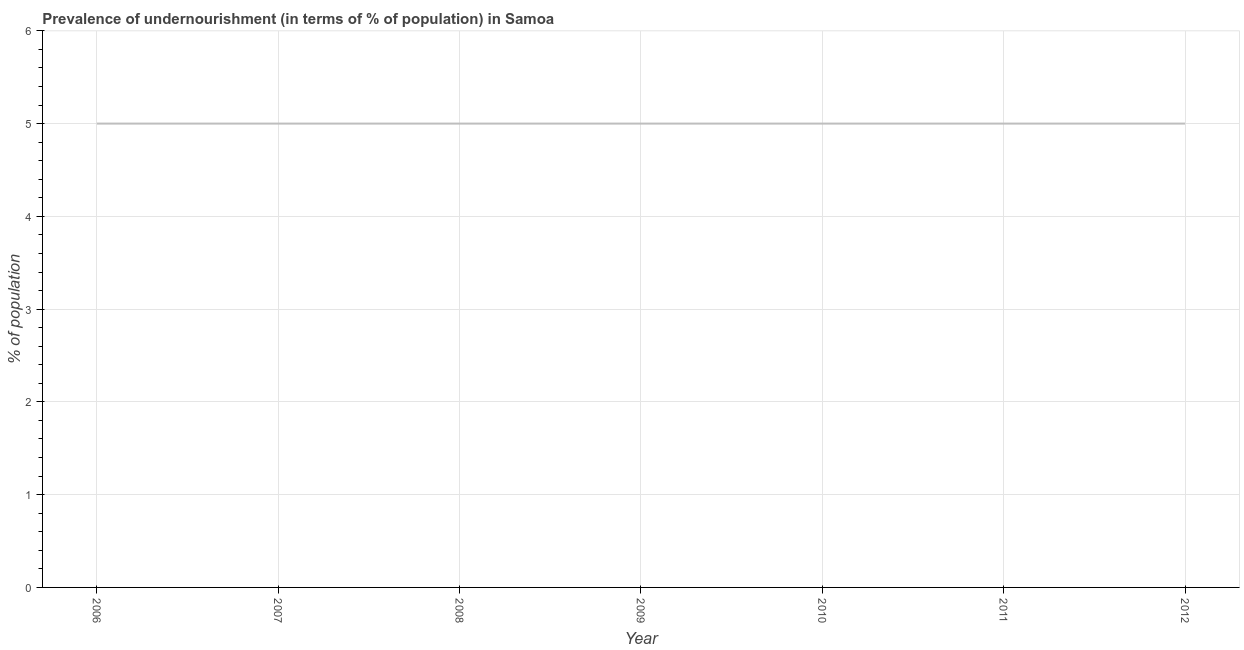What is the percentage of undernourished population in 2009?
Your answer should be compact. 5. Across all years, what is the maximum percentage of undernourished population?
Offer a terse response. 5. In which year was the percentage of undernourished population maximum?
Make the answer very short. 2006. What is the difference between the percentage of undernourished population in 2009 and 2011?
Offer a very short reply. 0. What is the median percentage of undernourished population?
Provide a succinct answer. 5. What is the ratio of the percentage of undernourished population in 2006 to that in 2011?
Keep it short and to the point. 1. Is the percentage of undernourished population in 2006 less than that in 2010?
Ensure brevity in your answer.  No. What is the difference between the highest and the second highest percentage of undernourished population?
Give a very brief answer. 0. In how many years, is the percentage of undernourished population greater than the average percentage of undernourished population taken over all years?
Your answer should be very brief. 0. Does the percentage of undernourished population monotonically increase over the years?
Ensure brevity in your answer.  No. How many lines are there?
Offer a very short reply. 1. How many years are there in the graph?
Provide a succinct answer. 7. Are the values on the major ticks of Y-axis written in scientific E-notation?
Keep it short and to the point. No. Does the graph contain any zero values?
Make the answer very short. No. What is the title of the graph?
Offer a terse response. Prevalence of undernourishment (in terms of % of population) in Samoa. What is the label or title of the Y-axis?
Your answer should be compact. % of population. What is the % of population of 2009?
Ensure brevity in your answer.  5. What is the % of population in 2011?
Provide a short and direct response. 5. What is the % of population in 2012?
Your answer should be very brief. 5. What is the difference between the % of population in 2006 and 2008?
Make the answer very short. 0. What is the difference between the % of population in 2006 and 2009?
Offer a very short reply. 0. What is the difference between the % of population in 2006 and 2010?
Provide a short and direct response. 0. What is the difference between the % of population in 2007 and 2009?
Your response must be concise. 0. What is the difference between the % of population in 2009 and 2012?
Make the answer very short. 0. What is the difference between the % of population in 2010 and 2011?
Keep it short and to the point. 0. What is the difference between the % of population in 2011 and 2012?
Provide a succinct answer. 0. What is the ratio of the % of population in 2006 to that in 2007?
Offer a very short reply. 1. What is the ratio of the % of population in 2006 to that in 2008?
Ensure brevity in your answer.  1. What is the ratio of the % of population in 2006 to that in 2009?
Give a very brief answer. 1. What is the ratio of the % of population in 2006 to that in 2012?
Ensure brevity in your answer.  1. What is the ratio of the % of population in 2007 to that in 2008?
Ensure brevity in your answer.  1. What is the ratio of the % of population in 2007 to that in 2009?
Your answer should be compact. 1. What is the ratio of the % of population in 2007 to that in 2011?
Give a very brief answer. 1. What is the ratio of the % of population in 2008 to that in 2009?
Your response must be concise. 1. What is the ratio of the % of population in 2008 to that in 2011?
Your answer should be very brief. 1. What is the ratio of the % of population in 2008 to that in 2012?
Provide a short and direct response. 1. What is the ratio of the % of population in 2009 to that in 2010?
Provide a succinct answer. 1. What is the ratio of the % of population in 2009 to that in 2011?
Your response must be concise. 1. What is the ratio of the % of population in 2010 to that in 2011?
Your answer should be compact. 1. What is the ratio of the % of population in 2011 to that in 2012?
Offer a terse response. 1. 